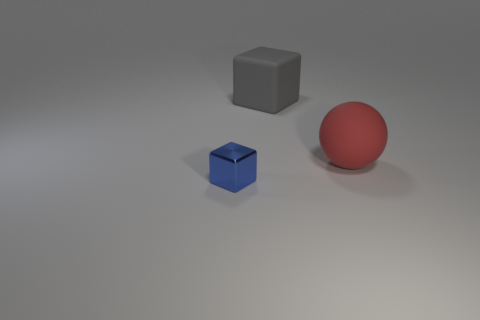Add 1 large matte balls. How many objects exist? 4 Subtract all blocks. How many objects are left? 1 Add 3 tiny blue metal blocks. How many tiny blue metal blocks are left? 4 Add 2 red rubber things. How many red rubber things exist? 3 Subtract 0 cyan cylinders. How many objects are left? 3 Subtract all rubber blocks. Subtract all matte objects. How many objects are left? 0 